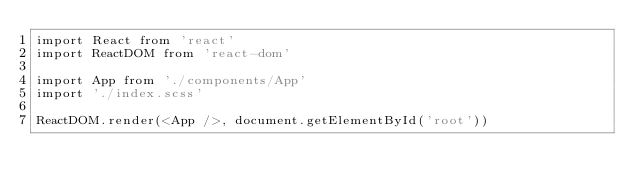<code> <loc_0><loc_0><loc_500><loc_500><_JavaScript_>import React from 'react'
import ReactDOM from 'react-dom'

import App from './components/App'
import './index.scss'

ReactDOM.render(<App />, document.getElementById('root'))
</code> 